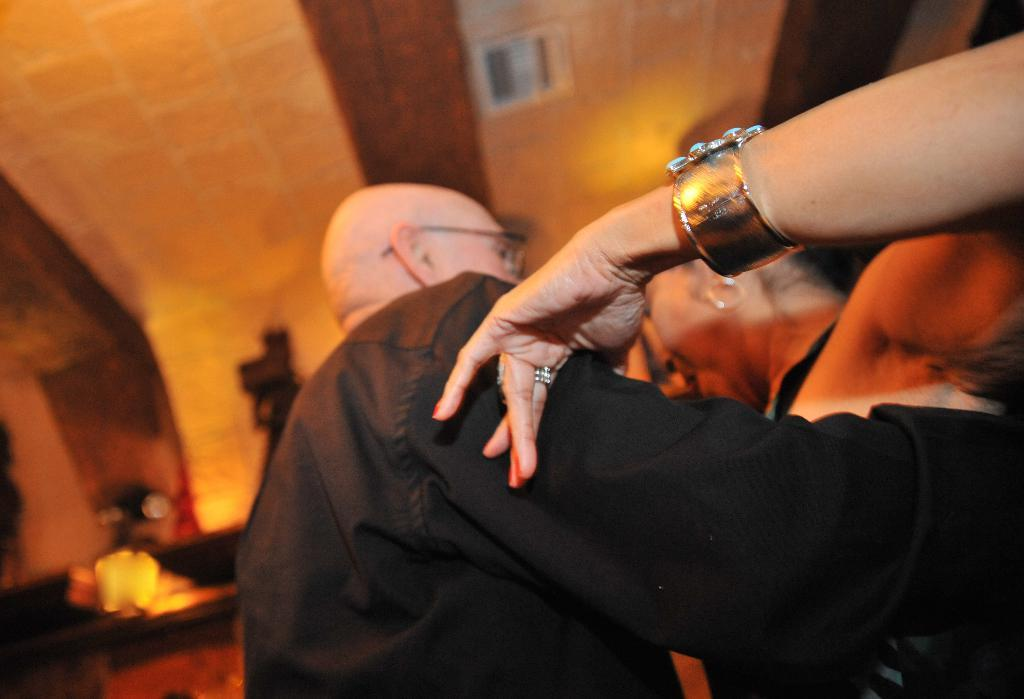Who are the two people in the image? There is a man and a woman in the image. What are the man and woman doing in the image? The man and woman are holding each other. What can be seen in the background of the image? There is a camera on a stand, a wall, and a roof in the background. What type of yard is visible in the image? There is no yard visible in the image; it features a man and a woman holding each other, with a camera, wall, and roof in the background. 